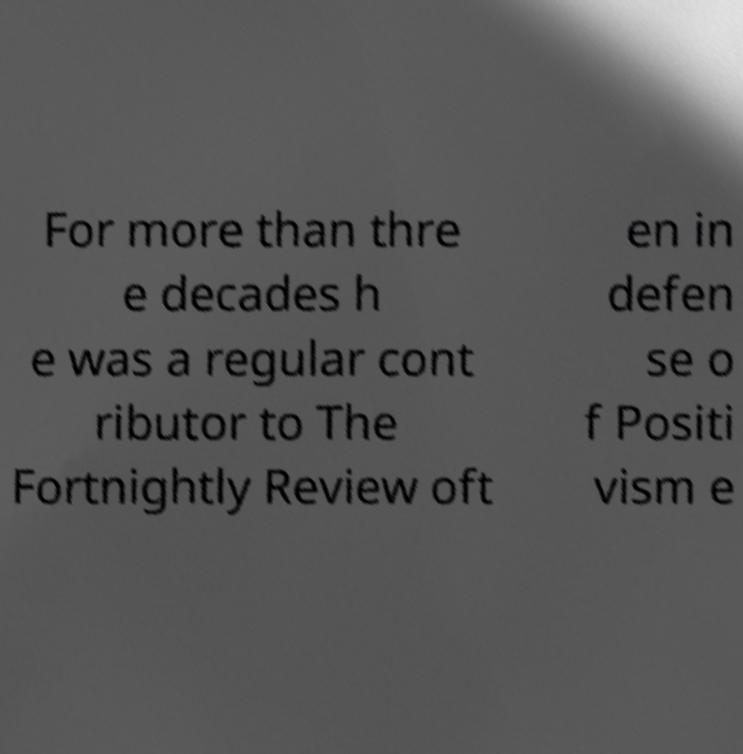For documentation purposes, I need the text within this image transcribed. Could you provide that? For more than thre e decades h e was a regular cont ributor to The Fortnightly Review oft en in defen se o f Positi vism e 